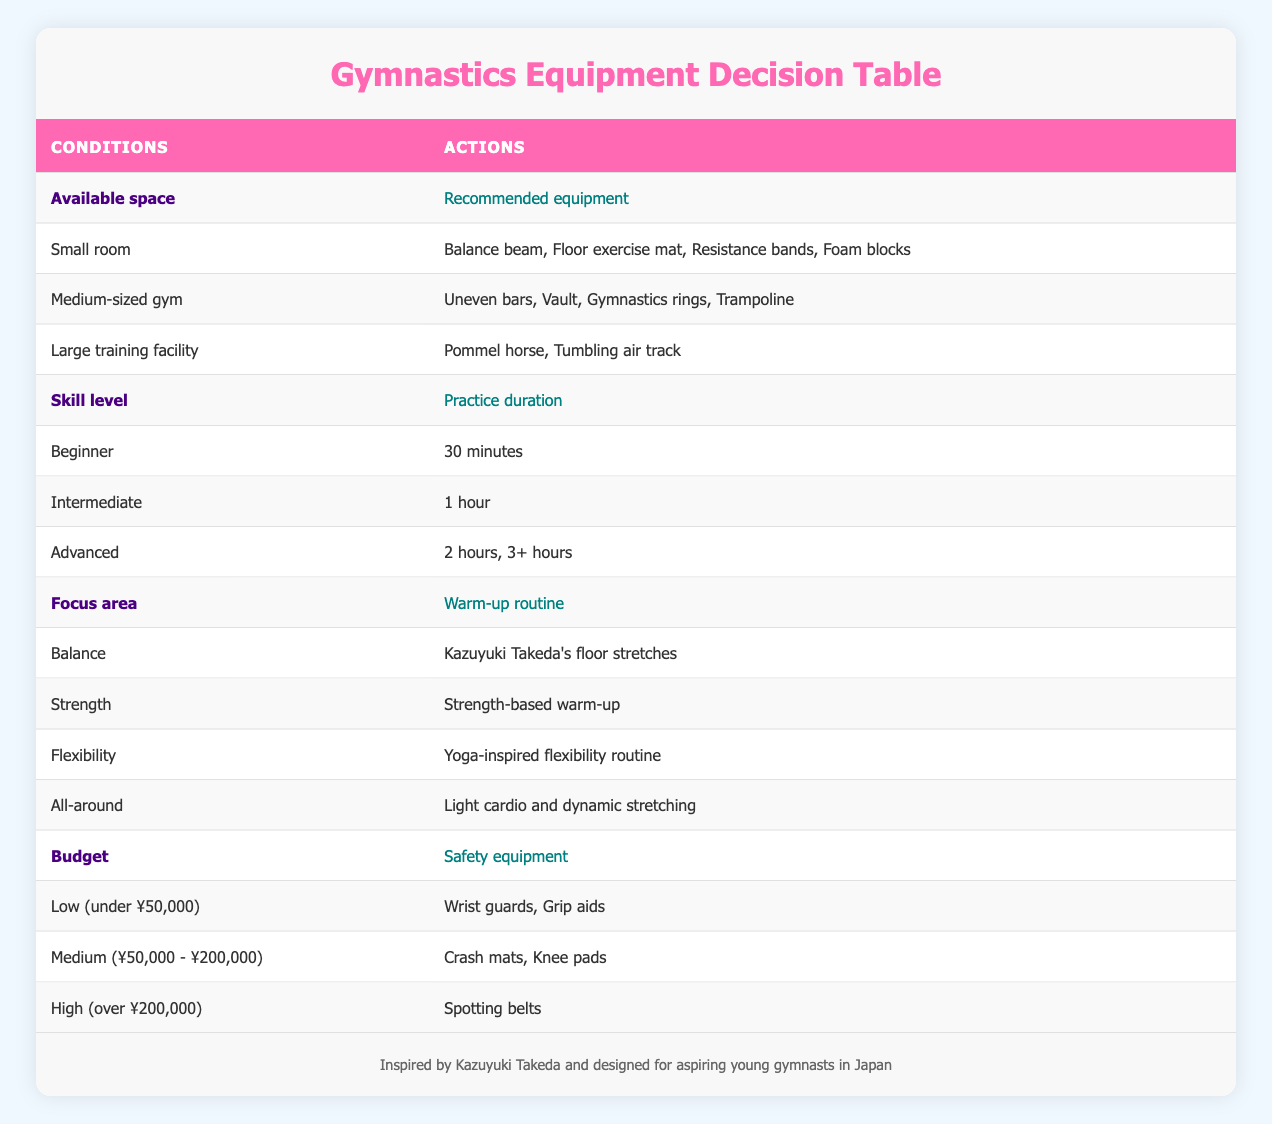What equipment is recommended for a small room space? In the table, under the "Available space" condition for a "Small room", the recommended equipment includes "Balance beam, Floor exercise mat, Resistance bands, Foam blocks".
Answer: Balance beam, Floor exercise mat, Resistance bands, Foam blocks What practice duration is suggested for an intermediate skill level? The table shows that for "Intermediate" skill level, the suggested practice duration is "1 hour".
Answer: 1 hour Is a trampoline recommended for a small room? The table indicates that "Trampoline" is listed under the recommended equipment for "Medium-sized gym" and not for "Small room", so it is not recommended for a small space.
Answer: No If my budget is high, what safety equipment can I use? Based on the table, for a "High (over ¥200,000)" budget, the safety equipment recommended is "Spotting belts".
Answer: Spotting belts How many different types of warm-up routines are suggested for different focus areas? The table provides four focus areas, each associated with a distinct warm-up routine: "Balance" with Kazuyuki Takeda's stretches, "Strength" with strength-based warm-up, "Flexibility" with yoga-inspired routine, and "All-around" with light cardio. Thus, there are four different warm-up routines.
Answer: 4 What is the total number of safety equipment options available for a medium budget? For a "Medium (¥50,000 - ¥200,000)" budget, the safety equipment options listed are "Crash mats, Knee pads", resulting in a total of two options available.
Answer: 2 For an advanced gymnast practicing for 3+ hours, what should their warm-up routine be if they focus on flexibility? The table indicates that for "Flexibility" focus area, the warm-up routine recommended is "Yoga-inspired flexibility routine". This recommendation applies regardless of practice duration so it remains the same.
Answer: Yoga-inspired flexibility routine If I have a medium-sized gym and am a beginner, what should I focus on during my warm-up? The available valid warm-up option for a "Beginner" skill level according to the focus area should align with "All-around" category which suggests light cardio and dynamic stretching, as beginners may not focus on specific areas yet.
Answer: Light cardio and dynamic stretching 